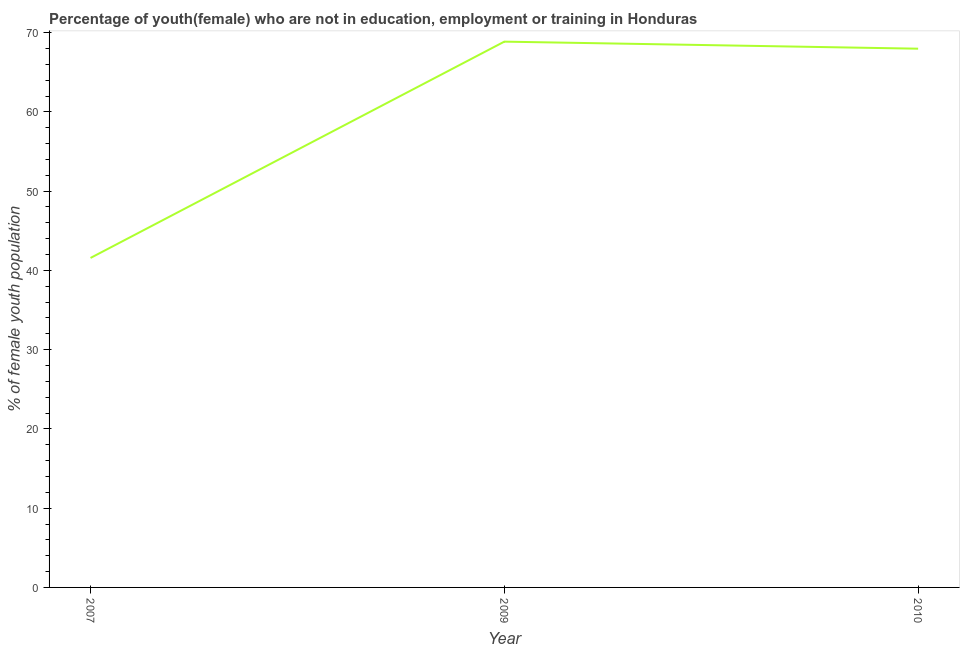What is the unemployed female youth population in 2007?
Give a very brief answer. 41.57. Across all years, what is the maximum unemployed female youth population?
Give a very brief answer. 68.86. Across all years, what is the minimum unemployed female youth population?
Give a very brief answer. 41.57. In which year was the unemployed female youth population minimum?
Provide a succinct answer. 2007. What is the sum of the unemployed female youth population?
Offer a very short reply. 178.4. What is the difference between the unemployed female youth population in 2007 and 2009?
Offer a terse response. -27.29. What is the average unemployed female youth population per year?
Provide a succinct answer. 59.47. What is the median unemployed female youth population?
Offer a terse response. 67.97. What is the ratio of the unemployed female youth population in 2007 to that in 2010?
Offer a very short reply. 0.61. Is the unemployed female youth population in 2009 less than that in 2010?
Keep it short and to the point. No. What is the difference between the highest and the second highest unemployed female youth population?
Give a very brief answer. 0.89. Is the sum of the unemployed female youth population in 2009 and 2010 greater than the maximum unemployed female youth population across all years?
Your answer should be very brief. Yes. What is the difference between the highest and the lowest unemployed female youth population?
Provide a short and direct response. 27.29. In how many years, is the unemployed female youth population greater than the average unemployed female youth population taken over all years?
Make the answer very short. 2. Does the unemployed female youth population monotonically increase over the years?
Give a very brief answer. No. Are the values on the major ticks of Y-axis written in scientific E-notation?
Make the answer very short. No. Does the graph contain grids?
Provide a short and direct response. No. What is the title of the graph?
Give a very brief answer. Percentage of youth(female) who are not in education, employment or training in Honduras. What is the label or title of the X-axis?
Give a very brief answer. Year. What is the label or title of the Y-axis?
Provide a short and direct response. % of female youth population. What is the % of female youth population of 2007?
Provide a succinct answer. 41.57. What is the % of female youth population of 2009?
Provide a succinct answer. 68.86. What is the % of female youth population of 2010?
Provide a short and direct response. 67.97. What is the difference between the % of female youth population in 2007 and 2009?
Offer a terse response. -27.29. What is the difference between the % of female youth population in 2007 and 2010?
Offer a very short reply. -26.4. What is the difference between the % of female youth population in 2009 and 2010?
Give a very brief answer. 0.89. What is the ratio of the % of female youth population in 2007 to that in 2009?
Provide a succinct answer. 0.6. What is the ratio of the % of female youth population in 2007 to that in 2010?
Offer a very short reply. 0.61. What is the ratio of the % of female youth population in 2009 to that in 2010?
Give a very brief answer. 1.01. 